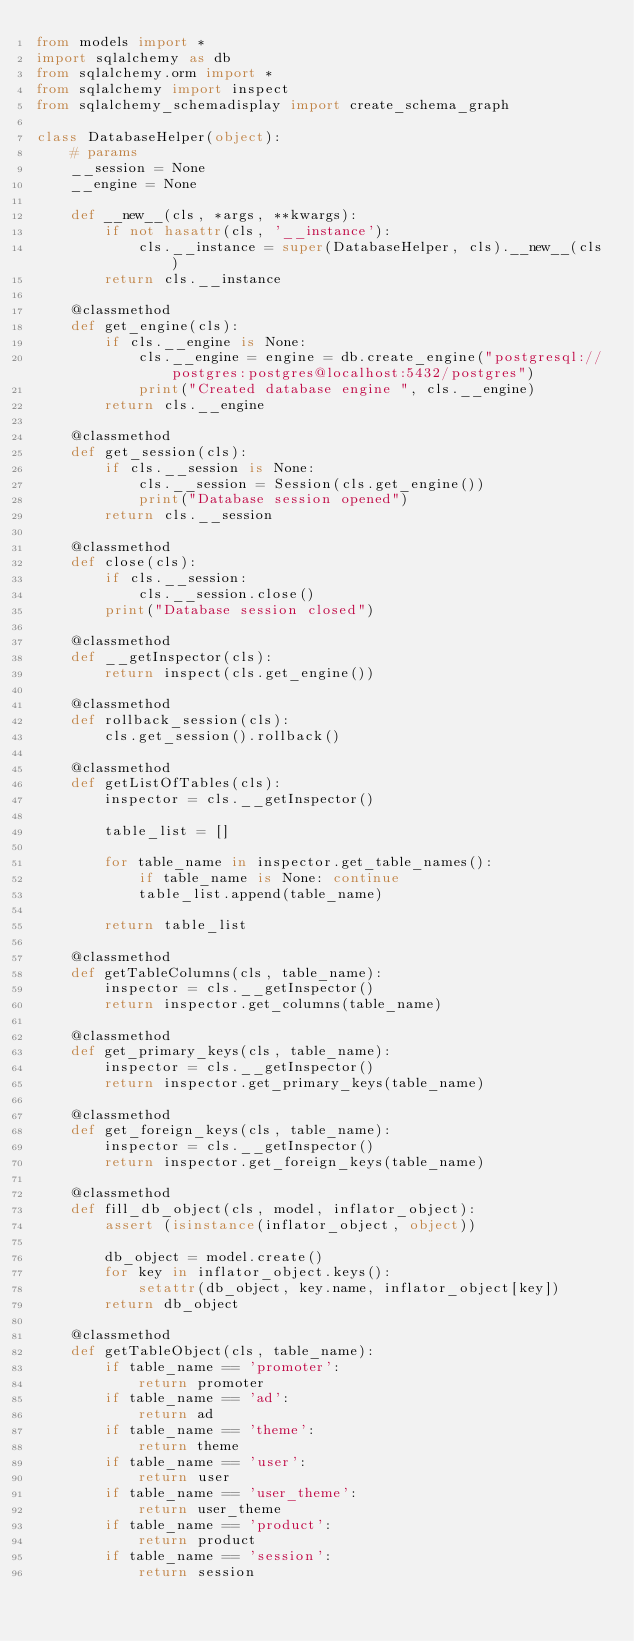<code> <loc_0><loc_0><loc_500><loc_500><_Python_>from models import *
import sqlalchemy as db
from sqlalchemy.orm import *
from sqlalchemy import inspect
from sqlalchemy_schemadisplay import create_schema_graph

class DatabaseHelper(object):
    # params
    __session = None
    __engine = None

    def __new__(cls, *args, **kwargs):
        if not hasattr(cls, '__instance'):
            cls.__instance = super(DatabaseHelper, cls).__new__(cls)
        return cls.__instance

    @classmethod
    def get_engine(cls):
        if cls.__engine is None:
            cls.__engine = engine = db.create_engine("postgresql://postgres:postgres@localhost:5432/postgres")
            print("Created database engine ", cls.__engine)
        return cls.__engine

    @classmethod
    def get_session(cls):
        if cls.__session is None:
            cls.__session = Session(cls.get_engine())
            print("Database session opened")
        return cls.__session

    @classmethod
    def close(cls):
        if cls.__session:
            cls.__session.close()
        print("Database session closed")

    @classmethod
    def __getInspector(cls):
        return inspect(cls.get_engine())

    @classmethod
    def rollback_session(cls):
        cls.get_session().rollback()

    @classmethod
    def getListOfTables(cls):
        inspector = cls.__getInspector()

        table_list = []

        for table_name in inspector.get_table_names():
            if table_name is None: continue
            table_list.append(table_name)

        return table_list

    @classmethod
    def getTableColumns(cls, table_name):
        inspector = cls.__getInspector()
        return inspector.get_columns(table_name)

    @classmethod
    def get_primary_keys(cls, table_name):
        inspector = cls.__getInspector()
        return inspector.get_primary_keys(table_name)

    @classmethod
    def get_foreign_keys(cls, table_name):
        inspector = cls.__getInspector()
        return inspector.get_foreign_keys(table_name)

    @classmethod
    def fill_db_object(cls, model, inflator_object):
        assert (isinstance(inflator_object, object))

        db_object = model.create()
        for key in inflator_object.keys():
            setattr(db_object, key.name, inflator_object[key])
        return db_object

    @classmethod
    def getTableObject(cls, table_name): 
        if table_name == 'promoter': 
            return promoter 
        if table_name == 'ad': 
            return ad 
        if table_name == 'theme': 
            return theme 
        if table_name == 'user': 
            return user 
        if table_name == 'user_theme': 
            return user_theme 
        if table_name == 'product': 
            return product 
        if table_name == 'session': 
            return session</code> 